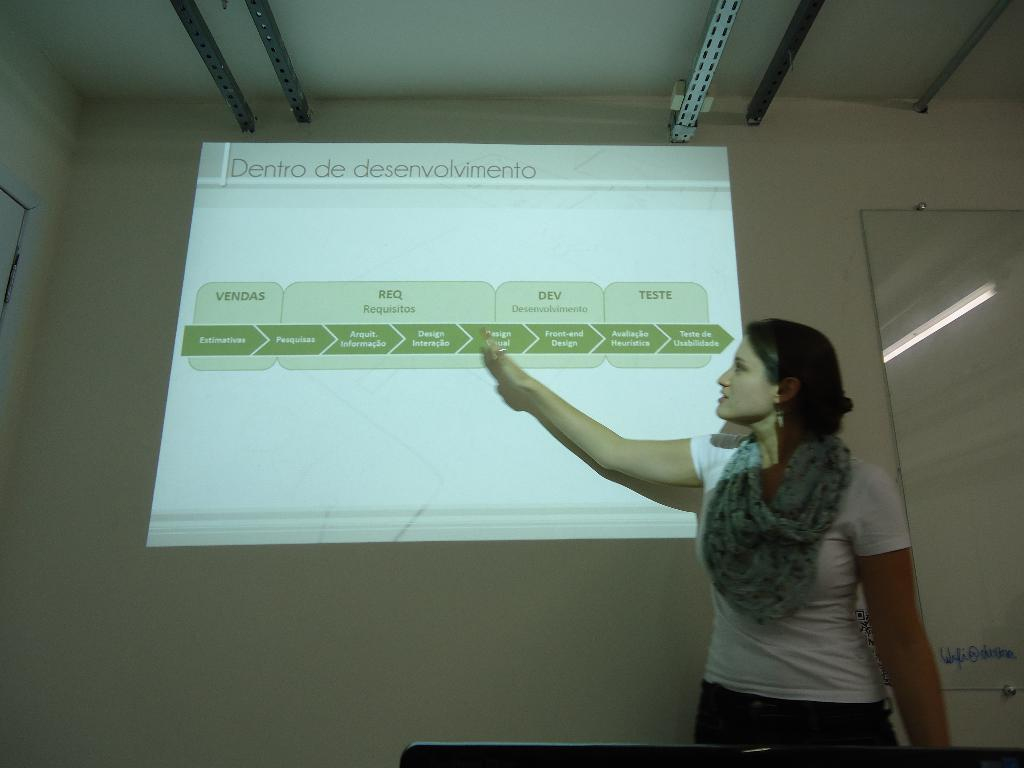<image>
Provide a brief description of the given image. A woman pointing to a slide show titled "Dentro de desenvolvimento." 